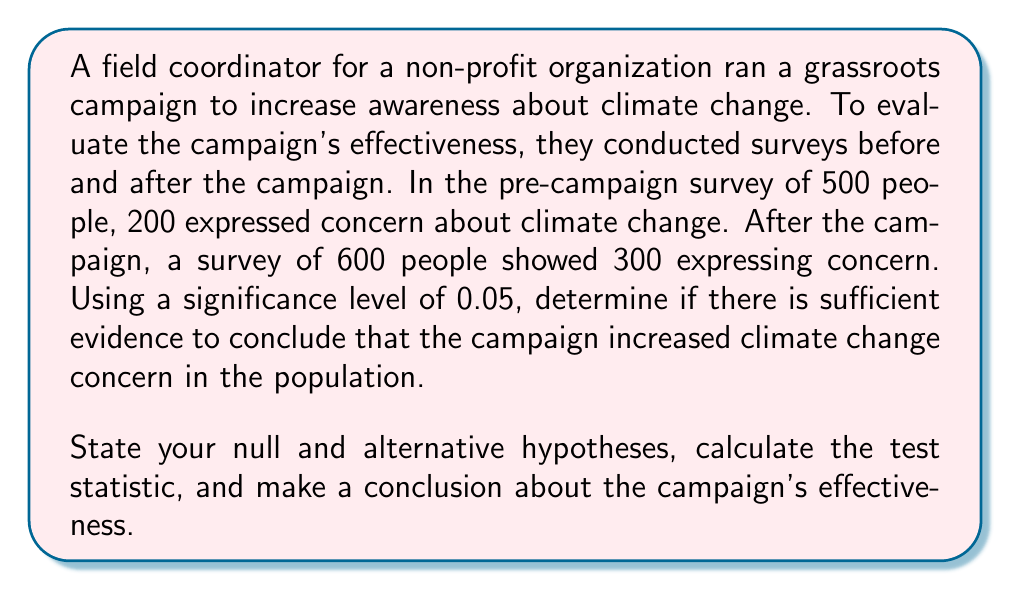Can you solve this math problem? To solve this problem, we'll use a two-proportion z-test. Let's go through it step-by-step:

1) Define the hypotheses:
   $H_0: p_1 = p_2$ (Null hypothesis: The proportion of people concerned about climate change is the same before and after the campaign)
   $H_a: p_1 < p_2$ (Alternative hypothesis: The proportion of people concerned about climate change is higher after the campaign)

2) Calculate the pooled sample proportion:
   $$\hat{p} = \frac{X_1 + X_2}{n_1 + n_2} = \frac{200 + 300}{500 + 600} = \frac{500}{1100} \approx 0.4545$$

3) Calculate the standard error:
   $$SE = \sqrt{\hat{p}(1-\hat{p})(\frac{1}{n_1} + \frac{1}{n_2})}$$
   $$SE = \sqrt{0.4545(1-0.4545)(\frac{1}{500} + \frac{1}{600})} \approx 0.0306$$

4) Calculate the test statistic:
   $$z = \frac{(\hat{p_2} - \hat{p_1}) - 0}{SE} = \frac{(\frac{300}{600} - \frac{200}{500}) - 0}{0.0306} \approx 2.1242$$

5) Find the critical value:
   For a one-tailed test at α = 0.05, the critical z-value is 1.645.

6) Make a decision:
   Since 2.1242 > 1.645, we reject the null hypothesis.

7) Conclusion:
   There is sufficient evidence at the 0.05 significance level to conclude that the campaign increased climate change concern in the population.
Answer: Reject $H_0$. There is statistically significant evidence that the campaign increased climate change concern (z ≈ 2.1242, p < 0.05). 